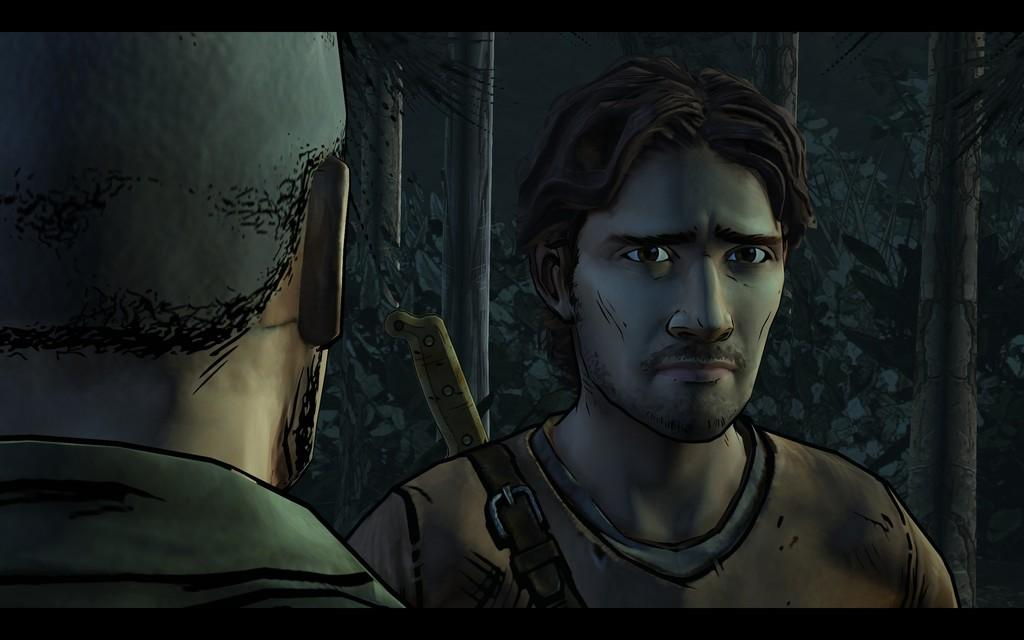How many people are present in the image? There are two men in the image. What can be seen in the background of the image? There are trees and plants in the background of the image. What type of shop can be seen in the image? There is no shop present in the image; it features two men and a background with trees and plants. How many giants are visible in the image? There are no giants present in the image; it features two men who are not depicted as being of unusual size. 